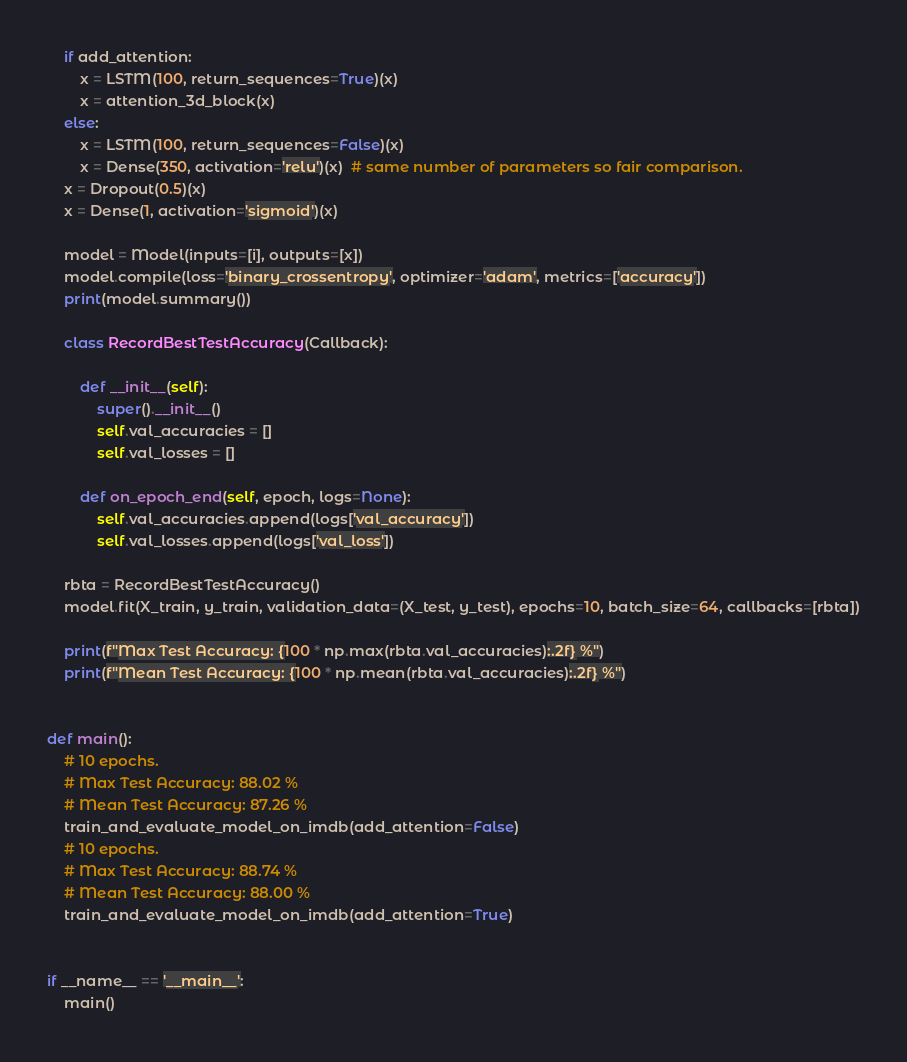<code> <loc_0><loc_0><loc_500><loc_500><_Python_>    if add_attention:
        x = LSTM(100, return_sequences=True)(x)
        x = attention_3d_block(x)
    else:
        x = LSTM(100, return_sequences=False)(x)
        x = Dense(350, activation='relu')(x)  # same number of parameters so fair comparison.
    x = Dropout(0.5)(x)
    x = Dense(1, activation='sigmoid')(x)

    model = Model(inputs=[i], outputs=[x])
    model.compile(loss='binary_crossentropy', optimizer='adam', metrics=['accuracy'])
    print(model.summary())

    class RecordBestTestAccuracy(Callback):

        def __init__(self):
            super().__init__()
            self.val_accuracies = []
            self.val_losses = []

        def on_epoch_end(self, epoch, logs=None):
            self.val_accuracies.append(logs['val_accuracy'])
            self.val_losses.append(logs['val_loss'])

    rbta = RecordBestTestAccuracy()
    model.fit(X_train, y_train, validation_data=(X_test, y_test), epochs=10, batch_size=64, callbacks=[rbta])

    print(f"Max Test Accuracy: {100 * np.max(rbta.val_accuracies):.2f} %")
    print(f"Mean Test Accuracy: {100 * np.mean(rbta.val_accuracies):.2f} %")


def main():
    # 10 epochs.
    # Max Test Accuracy: 88.02 %
    # Mean Test Accuracy: 87.26 %
    train_and_evaluate_model_on_imdb(add_attention=False)
    # 10 epochs.
    # Max Test Accuracy: 88.74 %
    # Mean Test Accuracy: 88.00 %
    train_and_evaluate_model_on_imdb(add_attention=True)


if __name__ == '__main__':
    main()
</code> 